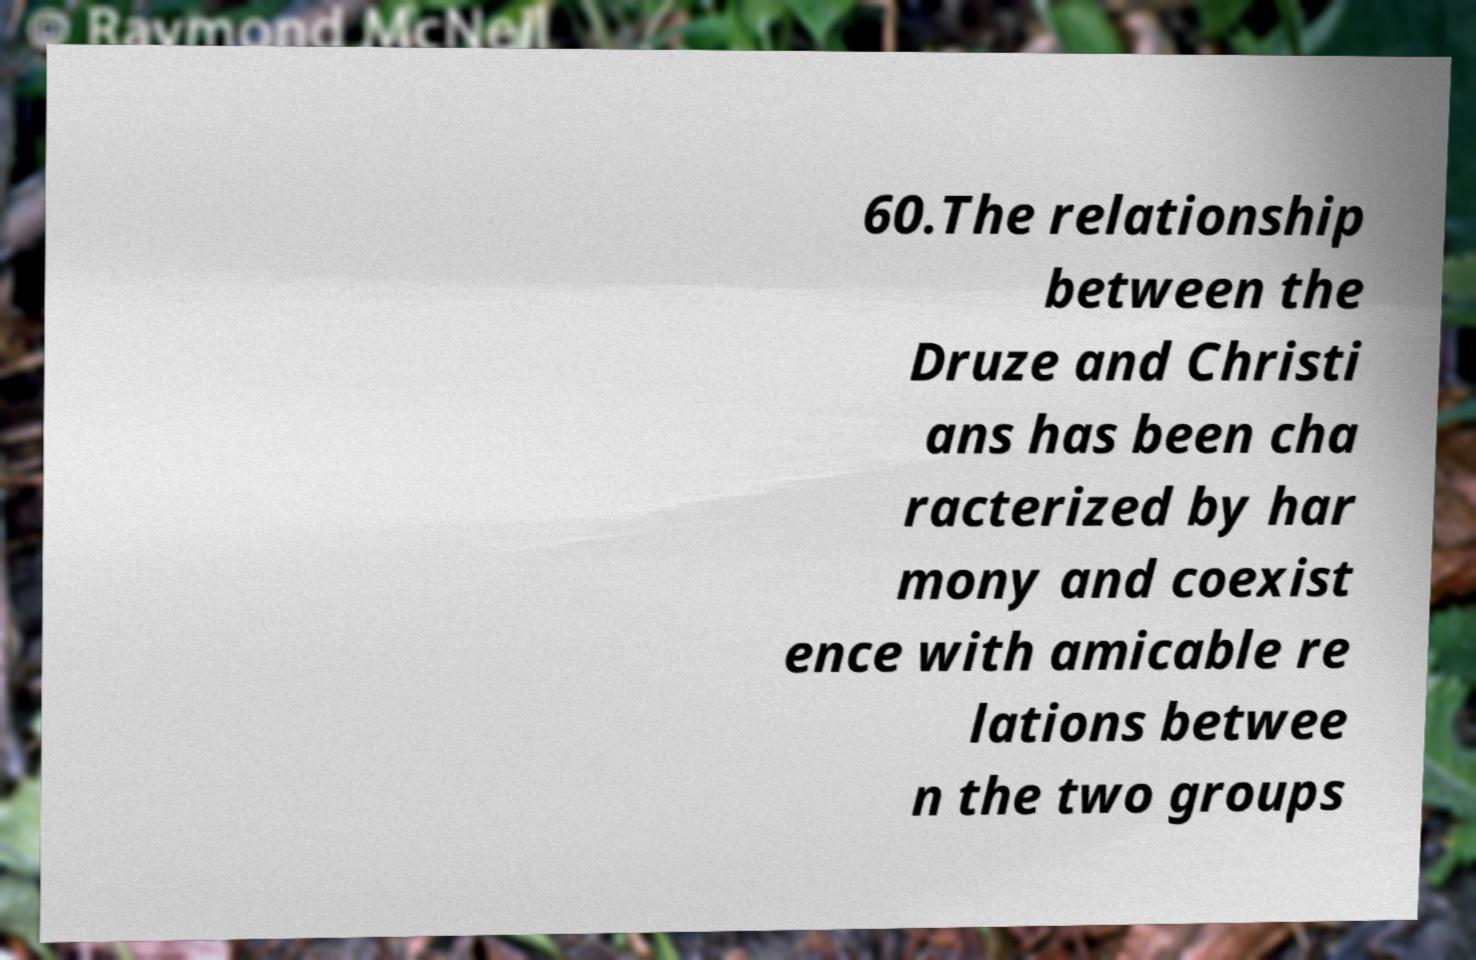What messages or text are displayed in this image? I need them in a readable, typed format. 60.The relationship between the Druze and Christi ans has been cha racterized by har mony and coexist ence with amicable re lations betwee n the two groups 